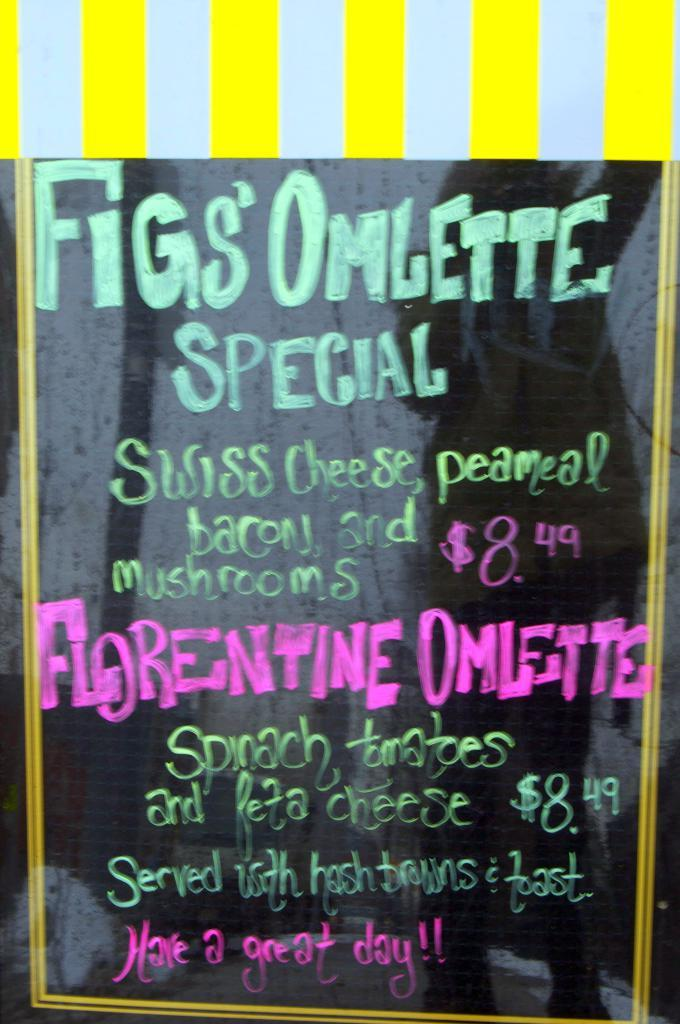<image>
Describe the image concisely. A hand-written restaurant sign advertises the fig's omlette special. 